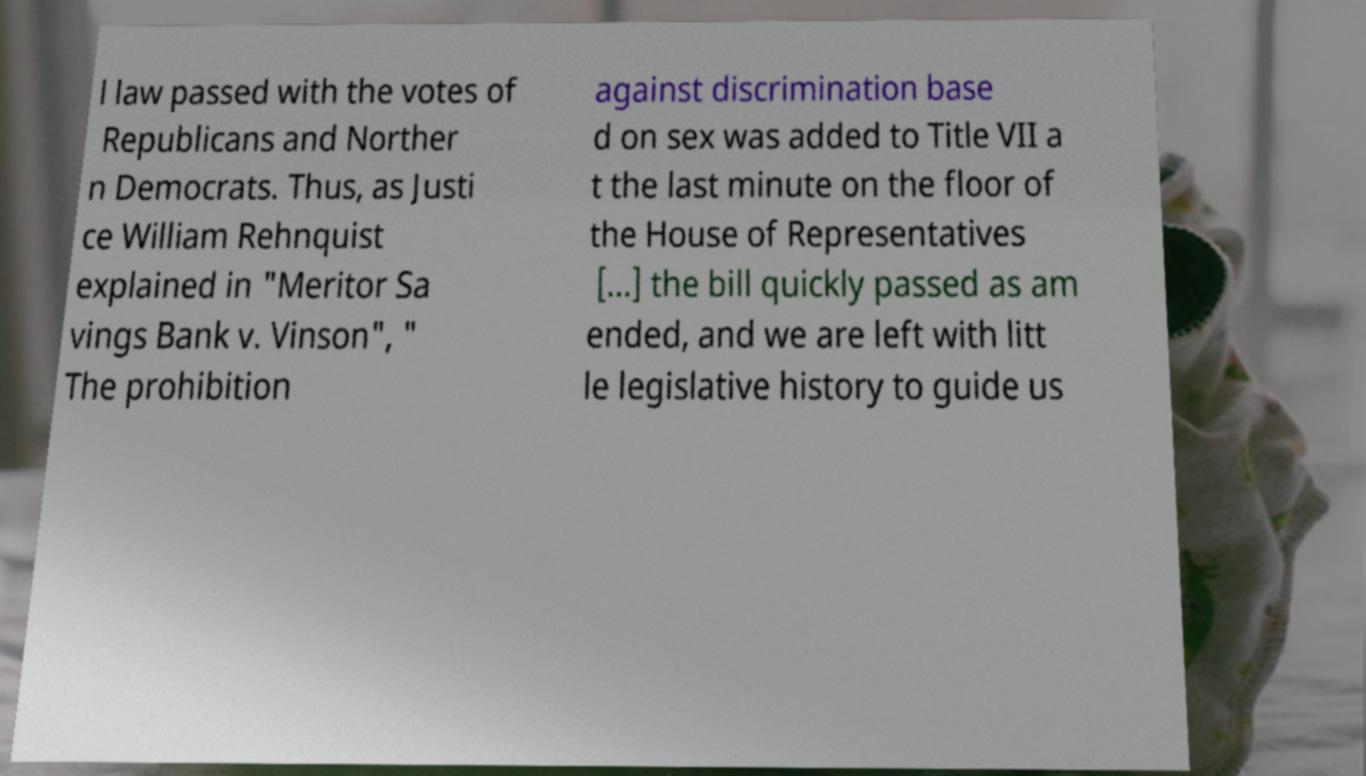Can you read and provide the text displayed in the image?This photo seems to have some interesting text. Can you extract and type it out for me? l law passed with the votes of Republicans and Norther n Democrats. Thus, as Justi ce William Rehnquist explained in "Meritor Sa vings Bank v. Vinson", " The prohibition against discrimination base d on sex was added to Title VII a t the last minute on the floor of the House of Representatives [...] the bill quickly passed as am ended, and we are left with litt le legislative history to guide us 